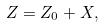Convert formula to latex. <formula><loc_0><loc_0><loc_500><loc_500>Z = Z _ { 0 } + X ,</formula> 